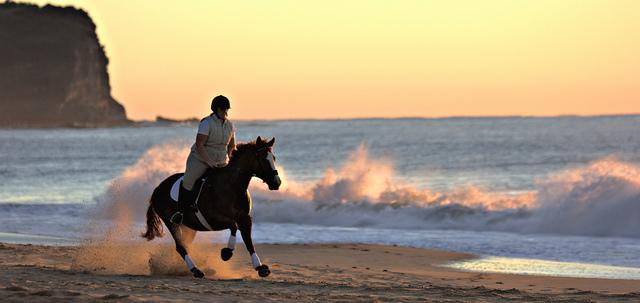Is this horse moving slowly?
Give a very brief answer. No. Where is the horse galloping to?
Keep it brief. Beach. Does this horse have tape around its legs?
Answer briefly. Yes. 